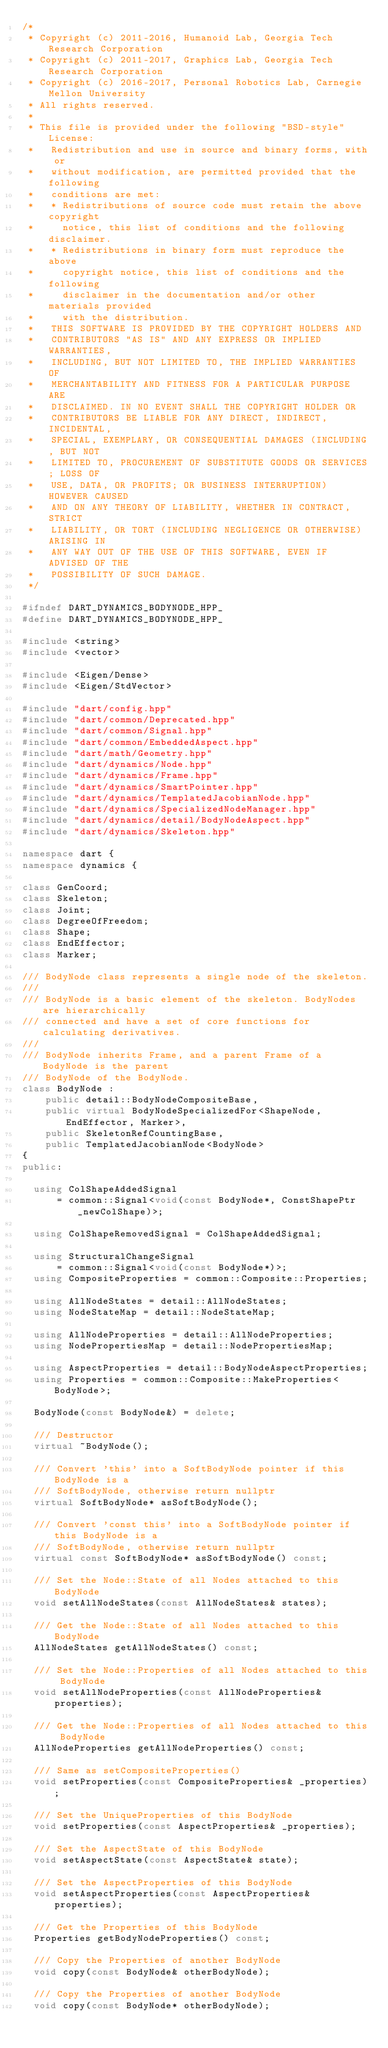<code> <loc_0><loc_0><loc_500><loc_500><_C++_>/*
 * Copyright (c) 2011-2016, Humanoid Lab, Georgia Tech Research Corporation
 * Copyright (c) 2011-2017, Graphics Lab, Georgia Tech Research Corporation
 * Copyright (c) 2016-2017, Personal Robotics Lab, Carnegie Mellon University
 * All rights reserved.
 *
 * This file is provided under the following "BSD-style" License:
 *   Redistribution and use in source and binary forms, with or
 *   without modification, are permitted provided that the following
 *   conditions are met:
 *   * Redistributions of source code must retain the above copyright
 *     notice, this list of conditions and the following disclaimer.
 *   * Redistributions in binary form must reproduce the above
 *     copyright notice, this list of conditions and the following
 *     disclaimer in the documentation and/or other materials provided
 *     with the distribution.
 *   THIS SOFTWARE IS PROVIDED BY THE COPYRIGHT HOLDERS AND
 *   CONTRIBUTORS "AS IS" AND ANY EXPRESS OR IMPLIED WARRANTIES,
 *   INCLUDING, BUT NOT LIMITED TO, THE IMPLIED WARRANTIES OF
 *   MERCHANTABILITY AND FITNESS FOR A PARTICULAR PURPOSE ARE
 *   DISCLAIMED. IN NO EVENT SHALL THE COPYRIGHT HOLDER OR
 *   CONTRIBUTORS BE LIABLE FOR ANY DIRECT, INDIRECT, INCIDENTAL,
 *   SPECIAL, EXEMPLARY, OR CONSEQUENTIAL DAMAGES (INCLUDING, BUT NOT
 *   LIMITED TO, PROCUREMENT OF SUBSTITUTE GOODS OR SERVICES; LOSS OF
 *   USE, DATA, OR PROFITS; OR BUSINESS INTERRUPTION) HOWEVER CAUSED
 *   AND ON ANY THEORY OF LIABILITY, WHETHER IN CONTRACT, STRICT
 *   LIABILITY, OR TORT (INCLUDING NEGLIGENCE OR OTHERWISE) ARISING IN
 *   ANY WAY OUT OF THE USE OF THIS SOFTWARE, EVEN IF ADVISED OF THE
 *   POSSIBILITY OF SUCH DAMAGE.
 */

#ifndef DART_DYNAMICS_BODYNODE_HPP_
#define DART_DYNAMICS_BODYNODE_HPP_

#include <string>
#include <vector>

#include <Eigen/Dense>
#include <Eigen/StdVector>

#include "dart/config.hpp"
#include "dart/common/Deprecated.hpp"
#include "dart/common/Signal.hpp"
#include "dart/common/EmbeddedAspect.hpp"
#include "dart/math/Geometry.hpp"
#include "dart/dynamics/Node.hpp"
#include "dart/dynamics/Frame.hpp"
#include "dart/dynamics/SmartPointer.hpp"
#include "dart/dynamics/TemplatedJacobianNode.hpp"
#include "dart/dynamics/SpecializedNodeManager.hpp"
#include "dart/dynamics/detail/BodyNodeAspect.hpp"
#include "dart/dynamics/Skeleton.hpp"

namespace dart {
namespace dynamics {

class GenCoord;
class Skeleton;
class Joint;
class DegreeOfFreedom;
class Shape;
class EndEffector;
class Marker;

/// BodyNode class represents a single node of the skeleton.
///
/// BodyNode is a basic element of the skeleton. BodyNodes are hierarchically
/// connected and have a set of core functions for calculating derivatives.
///
/// BodyNode inherits Frame, and a parent Frame of a BodyNode is the parent
/// BodyNode of the BodyNode.
class BodyNode :
    public detail::BodyNodeCompositeBase,
    public virtual BodyNodeSpecializedFor<ShapeNode, EndEffector, Marker>,
    public SkeletonRefCountingBase,
    public TemplatedJacobianNode<BodyNode>
{
public:

  using ColShapeAddedSignal
      = common::Signal<void(const BodyNode*, ConstShapePtr _newColShape)>;

  using ColShapeRemovedSignal = ColShapeAddedSignal;

  using StructuralChangeSignal
      = common::Signal<void(const BodyNode*)>;
  using CompositeProperties = common::Composite::Properties;

  using AllNodeStates = detail::AllNodeStates;
  using NodeStateMap = detail::NodeStateMap;

  using AllNodeProperties = detail::AllNodeProperties;
  using NodePropertiesMap = detail::NodePropertiesMap;

  using AspectProperties = detail::BodyNodeAspectProperties;
  using Properties = common::Composite::MakeProperties<BodyNode>;

  BodyNode(const BodyNode&) = delete;

  /// Destructor
  virtual ~BodyNode();

  /// Convert 'this' into a SoftBodyNode pointer if this BodyNode is a
  /// SoftBodyNode, otherwise return nullptr
  virtual SoftBodyNode* asSoftBodyNode();

  /// Convert 'const this' into a SoftBodyNode pointer if this BodyNode is a
  /// SoftBodyNode, otherwise return nullptr
  virtual const SoftBodyNode* asSoftBodyNode() const;

  /// Set the Node::State of all Nodes attached to this BodyNode
  void setAllNodeStates(const AllNodeStates& states);

  /// Get the Node::State of all Nodes attached to this BodyNode
  AllNodeStates getAllNodeStates() const;

  /// Set the Node::Properties of all Nodes attached to this BodyNode
  void setAllNodeProperties(const AllNodeProperties& properties);

  /// Get the Node::Properties of all Nodes attached to this BodyNode
  AllNodeProperties getAllNodeProperties() const;

  /// Same as setCompositeProperties()
  void setProperties(const CompositeProperties& _properties);

  /// Set the UniqueProperties of this BodyNode
  void setProperties(const AspectProperties& _properties);

  /// Set the AspectState of this BodyNode
  void setAspectState(const AspectState& state);

  /// Set the AspectProperties of this BodyNode
  void setAspectProperties(const AspectProperties& properties);

  /// Get the Properties of this BodyNode
  Properties getBodyNodeProperties() const;

  /// Copy the Properties of another BodyNode
  void copy(const BodyNode& otherBodyNode);

  /// Copy the Properties of another BodyNode
  void copy(const BodyNode* otherBodyNode);
</code> 